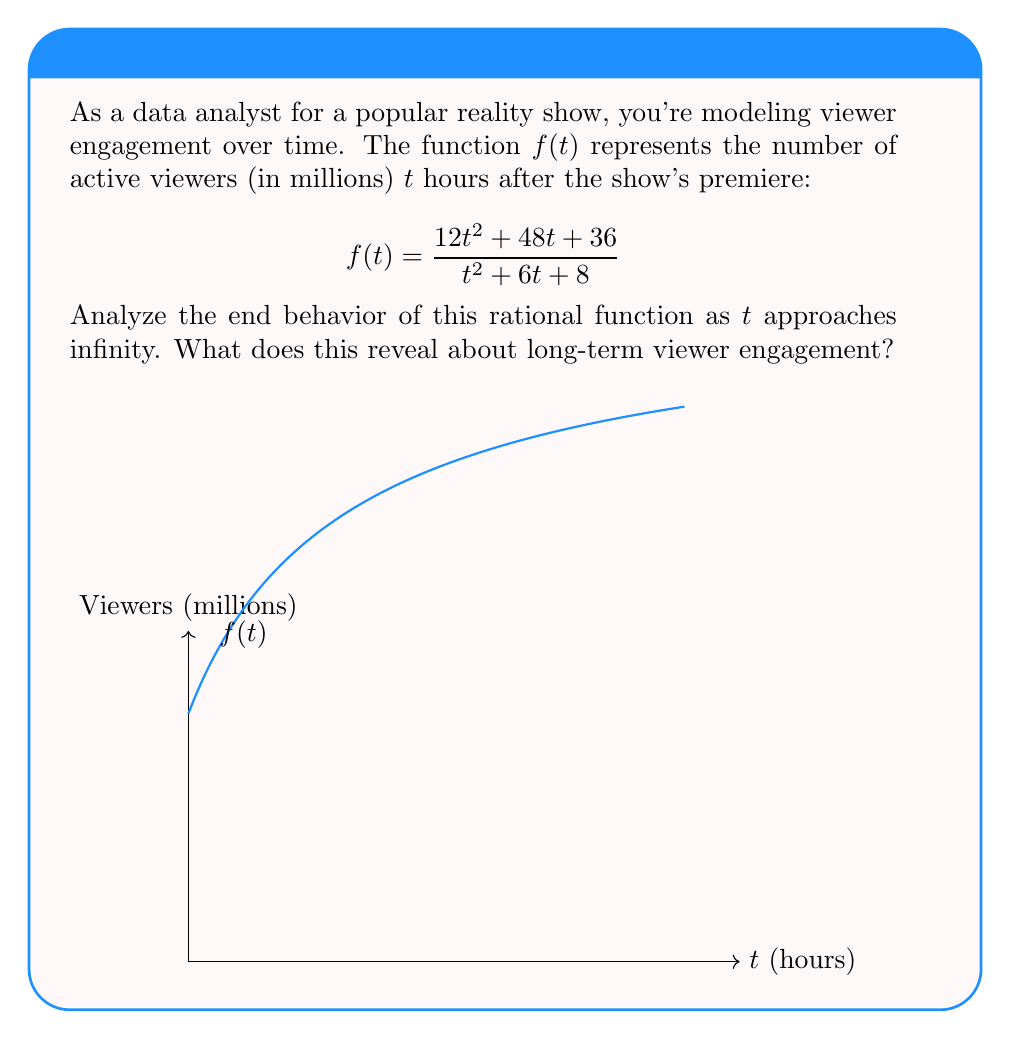Can you solve this math problem? Let's analyze the end behavior step-by-step:

1) To find the limit as $t$ approaches infinity, we need to look at the highest degree terms in the numerator and denominator.

2) Numerator: $12t^2 + 48t + 36$
   Denominator: $t^2 + 6t + 8$

3) Both have degree 2, so we divide the coefficients of the $t^2$ terms:

   $$\lim_{t \to \infty} f(t) = \lim_{t \to \infty} \frac{12t^2 + 48t + 36}{t^2 + 6t + 8} = \frac{12}{1} = 12$$

4) We can confirm this by dividing both numerator and denominator by $t^2$:

   $$\lim_{t \to \infty} \frac{12 + \frac{48}{t} + \frac{36}{t^2}}{1 + \frac{6}{t} + \frac{8}{t^2}} = \frac{12 + 0 + 0}{1 + 0 + 0} = 12$$

5) This means that as time goes to infinity, the function approaches 12 million viewers.

6) In terms of viewer engagement, this suggests that the show's audience stabilizes at around 12 million viewers in the long run, regardless of initial fluctuations.
Answer: $\lim_{t \to \infty} f(t) = 12$ million viewers 